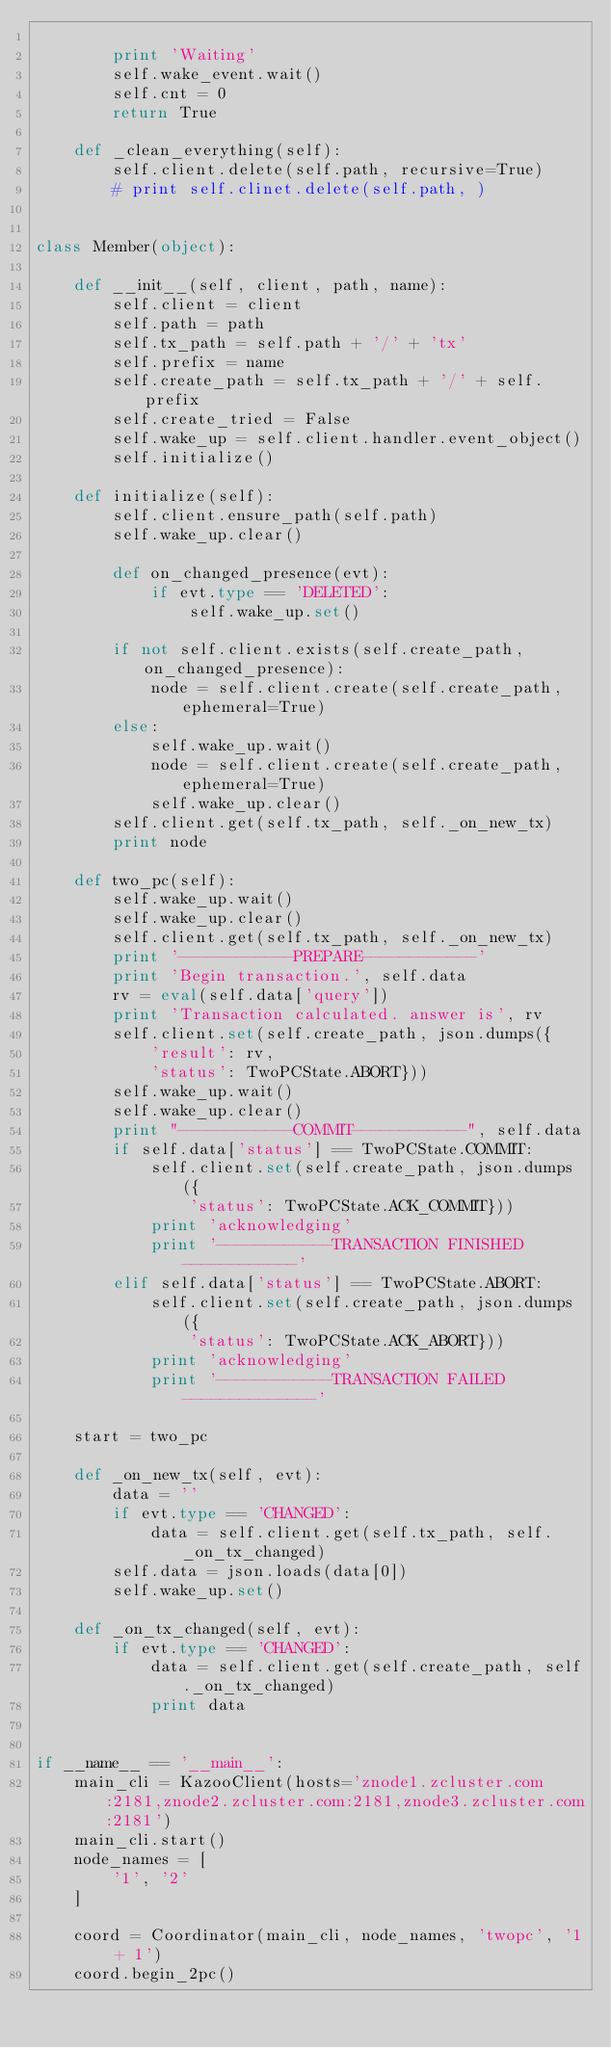<code> <loc_0><loc_0><loc_500><loc_500><_Python_>
        print 'Waiting'
        self.wake_event.wait()
        self.cnt = 0
        return True

    def _clean_everything(self):
        self.client.delete(self.path, recursive=True)
        # print self.clinet.delete(self.path, )


class Member(object):

    def __init__(self, client, path, name):
        self.client = client
        self.path = path
        self.tx_path = self.path + '/' + 'tx'
        self.prefix = name
        self.create_path = self.tx_path + '/' + self.prefix
        self.create_tried = False
        self.wake_up = self.client.handler.event_object()
        self.initialize()

    def initialize(self):
        self.client.ensure_path(self.path)
        self.wake_up.clear()

        def on_changed_presence(evt):
            if evt.type == 'DELETED':
                self.wake_up.set()

        if not self.client.exists(self.create_path, on_changed_presence):
            node = self.client.create(self.create_path, ephemeral=True)
        else:
            self.wake_up.wait()
            node = self.client.create(self.create_path, ephemeral=True)
            self.wake_up.clear()
        self.client.get(self.tx_path, self._on_new_tx)
        print node

    def two_pc(self):
        self.wake_up.wait()
        self.wake_up.clear()
        self.client.get(self.tx_path, self._on_new_tx)
        print '------------PREPARE------------'
        print 'Begin transaction.', self.data
        rv = eval(self.data['query'])
        print 'Transaction calculated. answer is', rv
        self.client.set(self.create_path, json.dumps({
            'result': rv,
            'status': TwoPCState.ABORT}))
        self.wake_up.wait()
        self.wake_up.clear()
        print "------------COMMIT------------", self.data
        if self.data['status'] == TwoPCState.COMMIT:
            self.client.set(self.create_path, json.dumps({
                'status': TwoPCState.ACK_COMMIT}))
            print 'acknowledging'
            print '------------TRANSACTION FINISHED------------'
        elif self.data['status'] == TwoPCState.ABORT:
            self.client.set(self.create_path, json.dumps({
                'status': TwoPCState.ACK_ABORT}))
            print 'acknowledging'
            print '------------TRANSACTION FAILED--------------'

    start = two_pc

    def _on_new_tx(self, evt):
        data = ''
        if evt.type == 'CHANGED':
            data = self.client.get(self.tx_path, self._on_tx_changed)
        self.data = json.loads(data[0])
        self.wake_up.set()

    def _on_tx_changed(self, evt):
        if evt.type == 'CHANGED':
            data = self.client.get(self.create_path, self._on_tx_changed)
            print data


if __name__ == '__main__':
    main_cli = KazooClient(hosts='znode1.zcluster.com:2181,znode2.zcluster.com:2181,znode3.zcluster.com:2181')
    main_cli.start()
    node_names = [
        '1', '2'
    ]

    coord = Coordinator(main_cli, node_names, 'twopc', '1 + 1')
    coord.begin_2pc()
</code> 